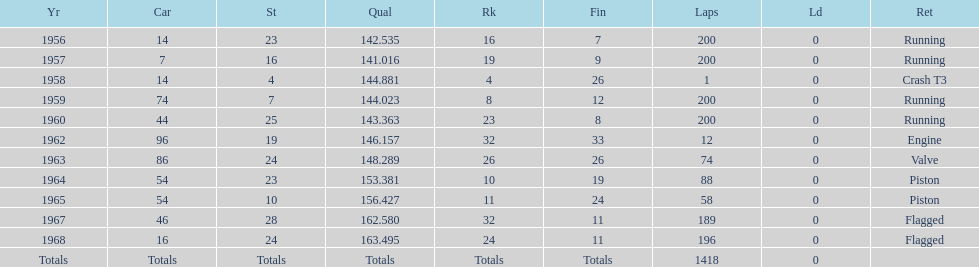Did bob veith drive more indy 500 laps in the 1950s or 1960s? 1960s. 